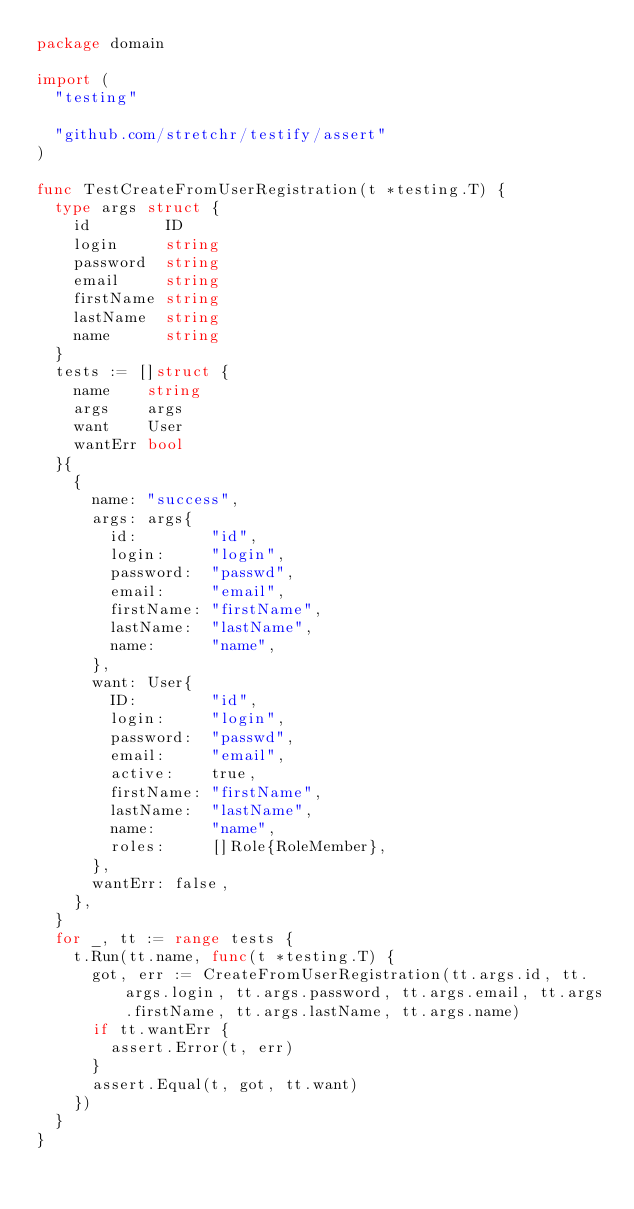Convert code to text. <code><loc_0><loc_0><loc_500><loc_500><_Go_>package domain

import (
	"testing"

	"github.com/stretchr/testify/assert"
)

func TestCreateFromUserRegistration(t *testing.T) {
	type args struct {
		id        ID
		login     string
		password  string
		email     string
		firstName string
		lastName  string
		name      string
	}
	tests := []struct {
		name    string
		args    args
		want    User
		wantErr bool
	}{
		{
			name: "success",
			args: args{
				id:        "id",
				login:     "login",
				password:  "passwd",
				email:     "email",
				firstName: "firstName",
				lastName:  "lastName",
				name:      "name",
			},
			want: User{
				ID:        "id",
				login:     "login",
				password:  "passwd",
				email:     "email",
				active:    true,
				firstName: "firstName",
				lastName:  "lastName",
				name:      "name",
				roles:     []Role{RoleMember},
			},
			wantErr: false,
		},
	}
	for _, tt := range tests {
		t.Run(tt.name, func(t *testing.T) {
			got, err := CreateFromUserRegistration(tt.args.id, tt.args.login, tt.args.password, tt.args.email, tt.args.firstName, tt.args.lastName, tt.args.name)
			if tt.wantErr {
				assert.Error(t, err)
			}
			assert.Equal(t, got, tt.want)
		})
	}
}
</code> 